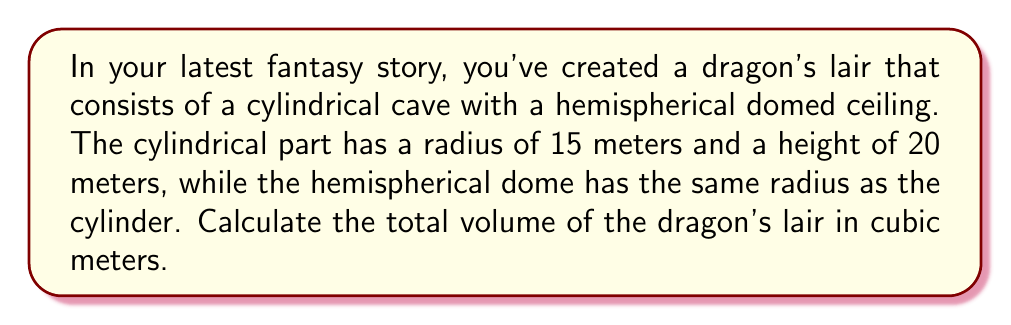Give your solution to this math problem. Let's break this down step-by-step:

1) The lair consists of two parts: a cylinder and a hemisphere.

2) For the cylinder:
   - Radius ($r$) = 15 m
   - Height ($h$) = 20 m
   - Volume of a cylinder is given by $V_c = \pi r^2 h$
   - $V_c = \pi \cdot 15^2 \cdot 20 = 14137.17$ m³

3) For the hemisphere:
   - Radius ($r$) = 15 m
   - Volume of a hemisphere is given by $V_h = \frac{2}{3}\pi r^3$
   - $V_h = \frac{2}{3} \pi \cdot 15^3 = 7068.58$ m³

4) Total volume of the lair:
   $V_{total} = V_c + V_h$
   $V_{total} = 14137.17 + 7068.58 = 21205.75$ m³

Therefore, the total volume of the dragon's lair is approximately 21205.75 cubic meters.
Answer: 21205.75 m³ 